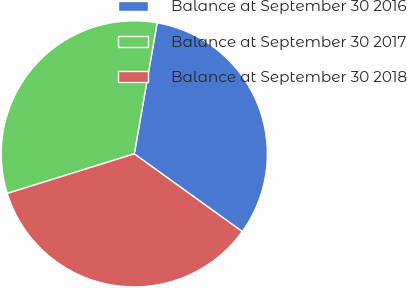<chart> <loc_0><loc_0><loc_500><loc_500><pie_chart><fcel>Balance at September 30 2016<fcel>Balance at September 30 2017<fcel>Balance at September 30 2018<nl><fcel>32.18%<fcel>32.56%<fcel>35.26%<nl></chart> 